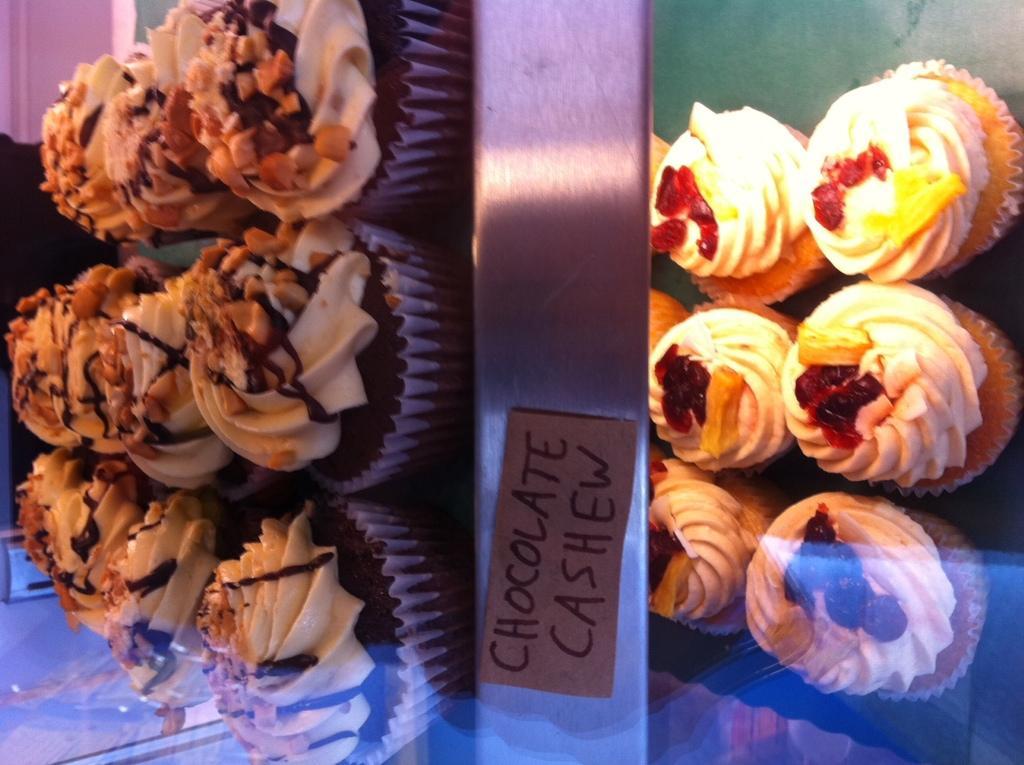Can you describe this image briefly? In the image we can see some chocolate cashews on a table. 